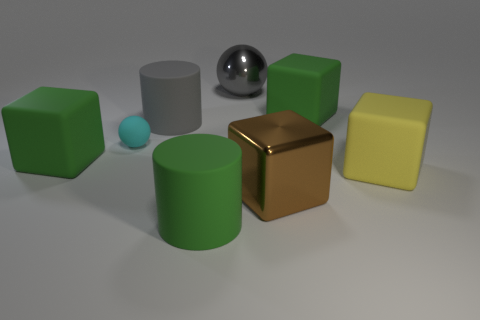Is there anything else that has the same size as the matte sphere?
Offer a terse response. No. What is the color of the shiny ball?
Offer a terse response. Gray. What size is the cyan ball right of the large object that is to the left of the ball that is to the left of the gray matte cylinder?
Offer a very short reply. Small. What number of other objects are the same size as the cyan sphere?
Provide a short and direct response. 0. How many small objects are the same material as the big gray cylinder?
Ensure brevity in your answer.  1. There is a large metal object on the right side of the gray metallic object; what is its shape?
Your answer should be very brief. Cube. Is the gray cylinder made of the same material as the large green cube to the right of the large gray metallic ball?
Provide a succinct answer. Yes. Is there a large green block?
Offer a terse response. Yes. Are there any gray matte objects left of the large green thing that is on the right side of the large shiny object behind the big yellow cube?
Your answer should be compact. Yes. How many small objects are either cyan matte balls or shiny balls?
Make the answer very short. 1. 